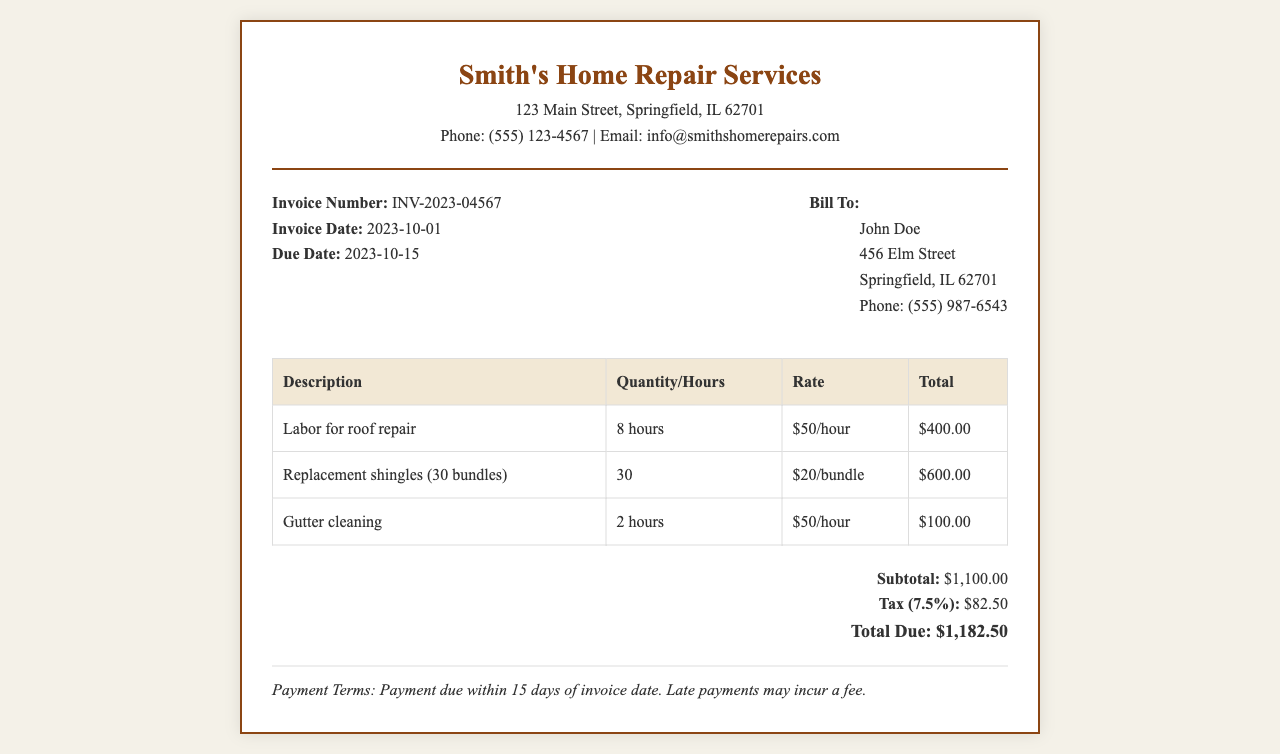What is the invoice number? The invoice number is clearly stated in the header section of the document.
Answer: INV-2023-04567 Who is the service provider? The service provider's name is located at the top of the invoice within the header.
Answer: Smith's Home Repair Services What is the total due amount? The total due is presented in the summary section of the invoice.
Answer: $1,182.50 How many hours were spent on gutter cleaning? The number of hours for gutter cleaning is detailed in the table under the labor description.
Answer: 2 hours What is the tax rate applied to the subtotal? The tax rate is mentioned in the summary section following the subtotal.
Answer: 7.5% What is the subtotal before tax? The subtotal is indicated in the summary section of the invoice right before tax is calculated.
Answer: $1,100.00 What date is the payment due? The payment due date is listed alongside the invoice date in the invoice details.
Answer: 2023-10-15 How many bundles of shingles were replaced? The quantity of shingles is indicated in the table specifying the materials used.
Answer: 30 What is the rate per hour for labor? The rate for labor is shown in the table next to the labor description.
Answer: $50/hour 